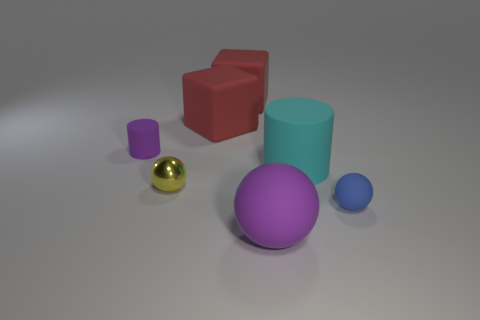Add 1 large matte things. How many objects exist? 8 Subtract all cylinders. How many objects are left? 5 Subtract 0 brown spheres. How many objects are left? 7 Subtract all big balls. Subtract all yellow things. How many objects are left? 5 Add 1 rubber things. How many rubber things are left? 7 Add 1 big rubber objects. How many big rubber objects exist? 5 